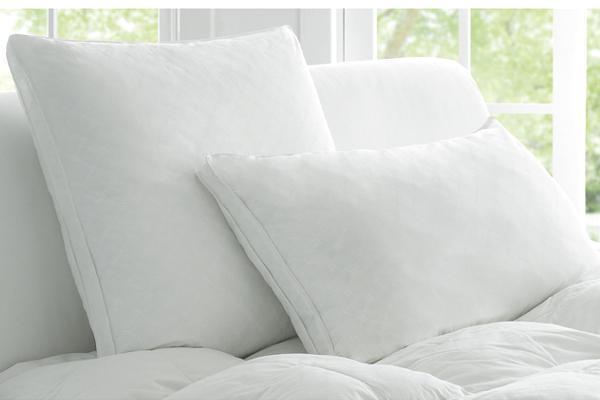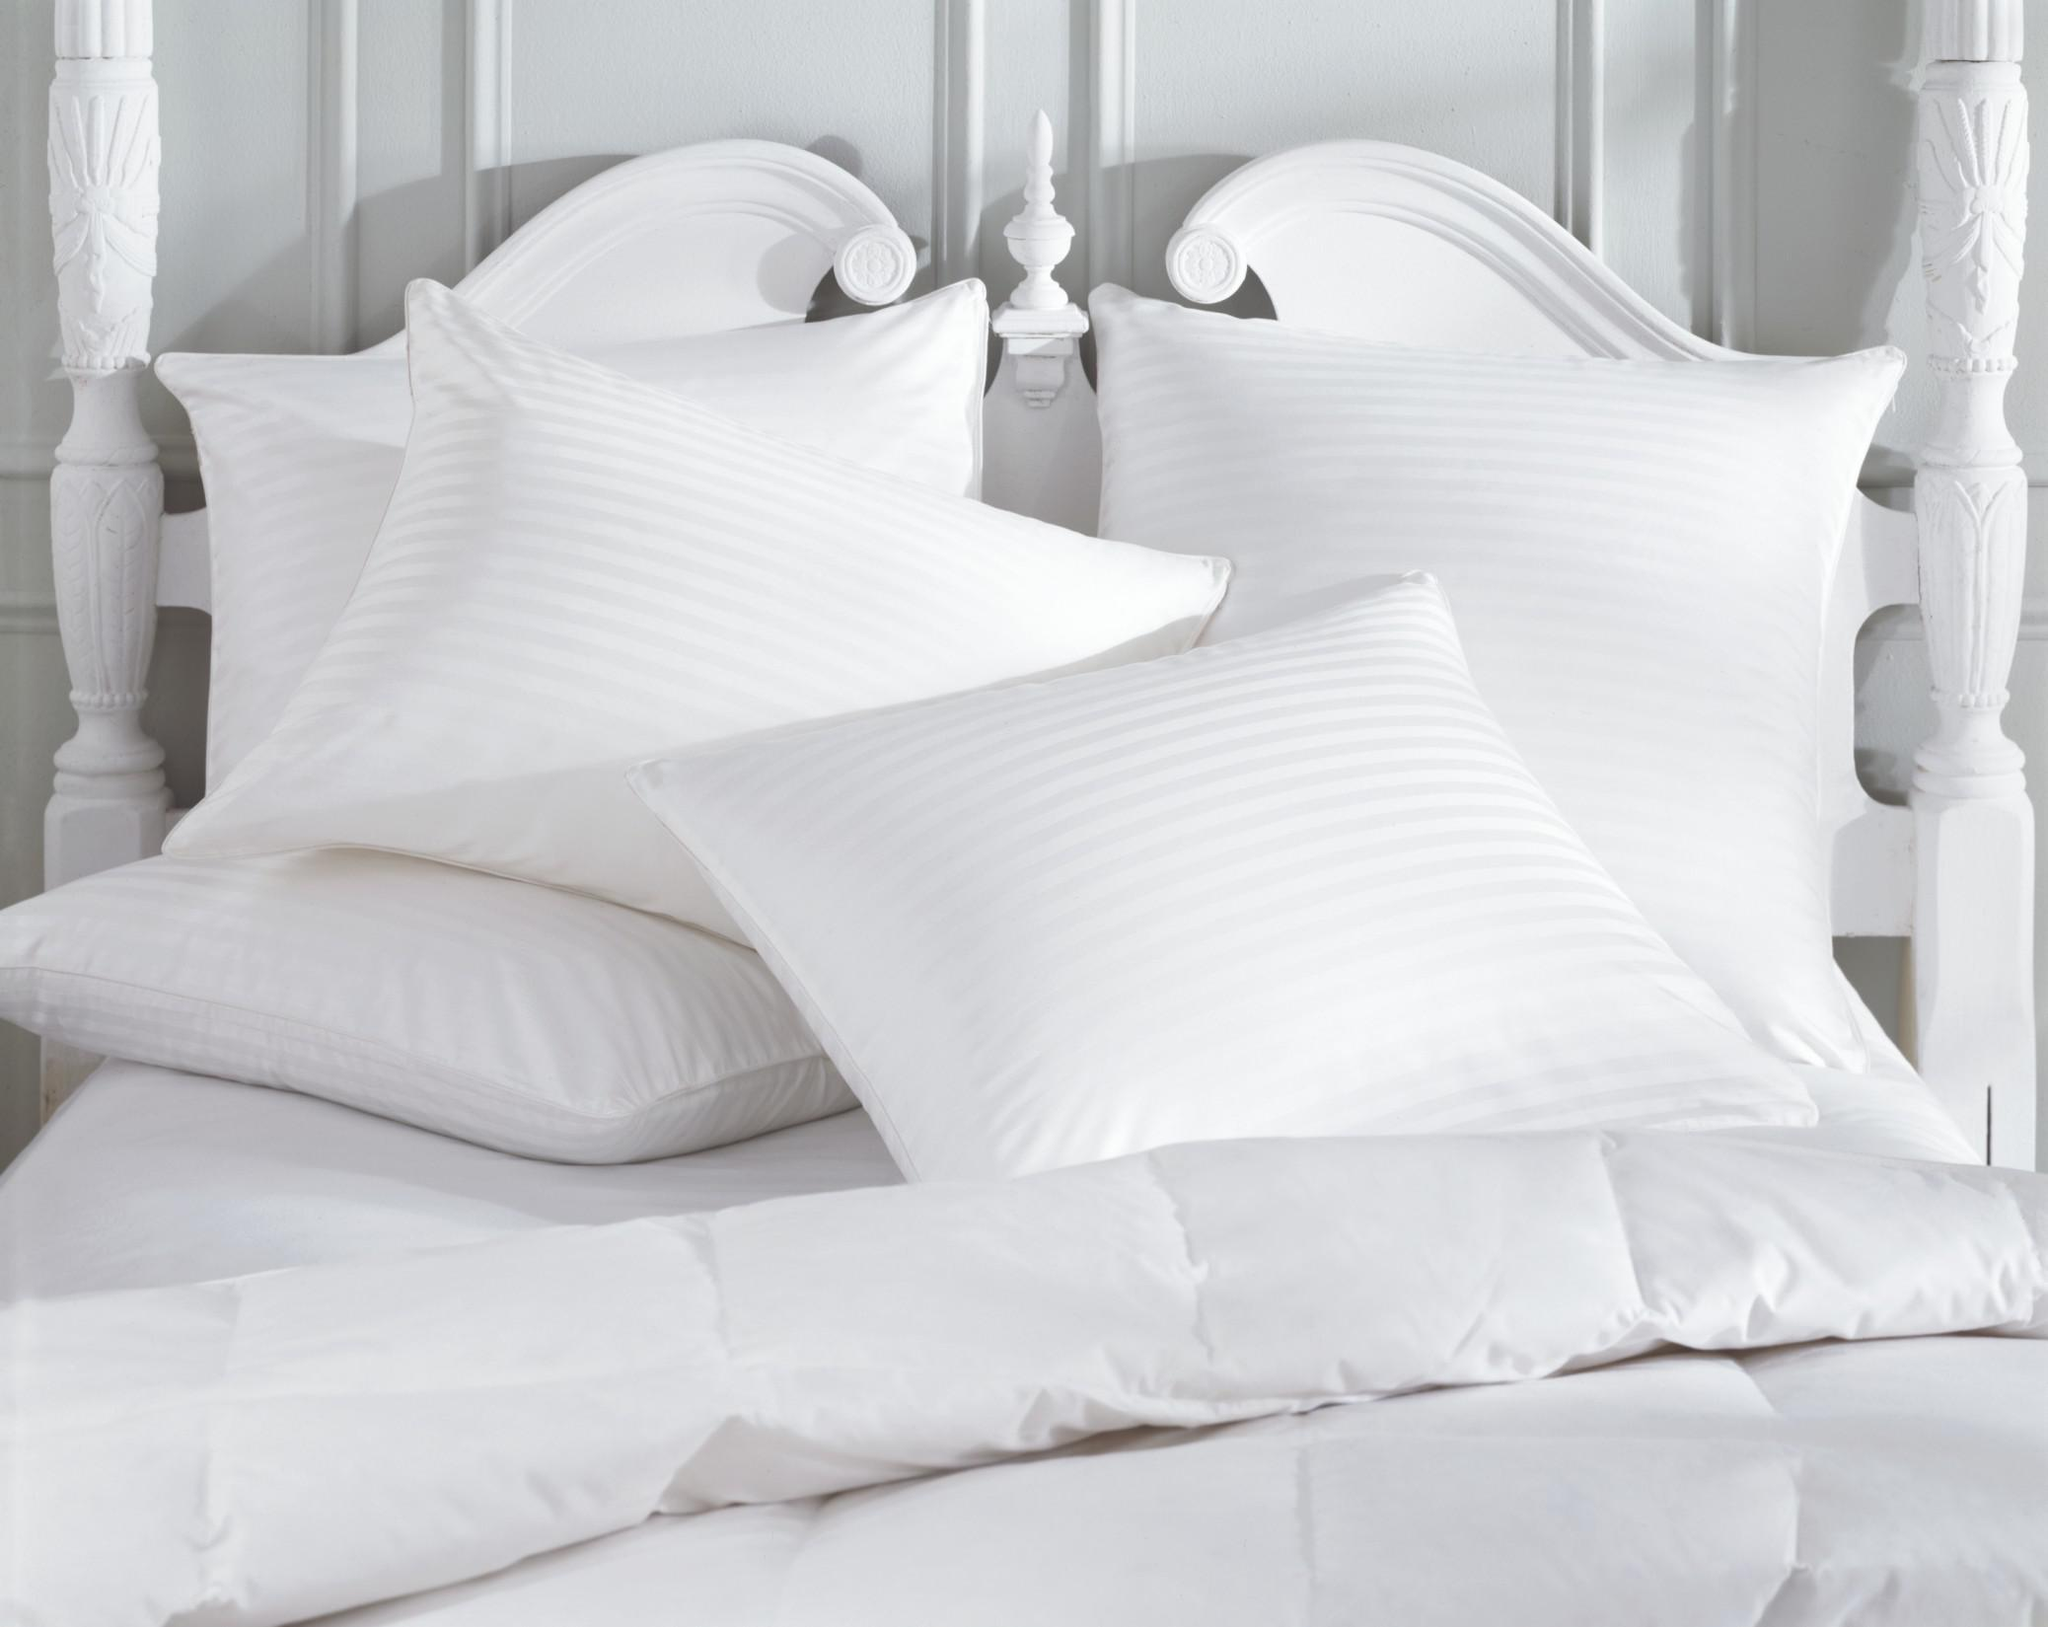The first image is the image on the left, the second image is the image on the right. Analyze the images presented: Is the assertion "One of the images contains exactly two white pillows." valid? Answer yes or no. Yes. 